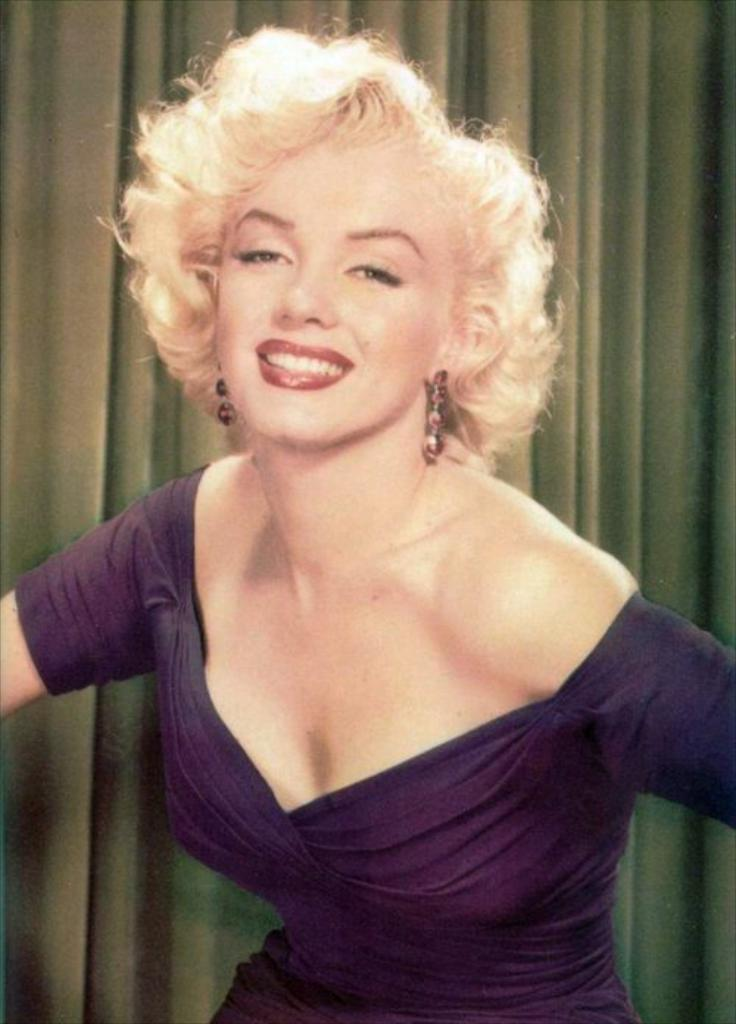Who is present in the image? There is a woman in the image. What is the woman doing in the image? The woman is watching something and smiling. What can be seen in the background of the image? There is a curtain in the background of the image. What type of meat is the woman eating in the image? There is no meat present in the image, and the woman is not eating anything. 